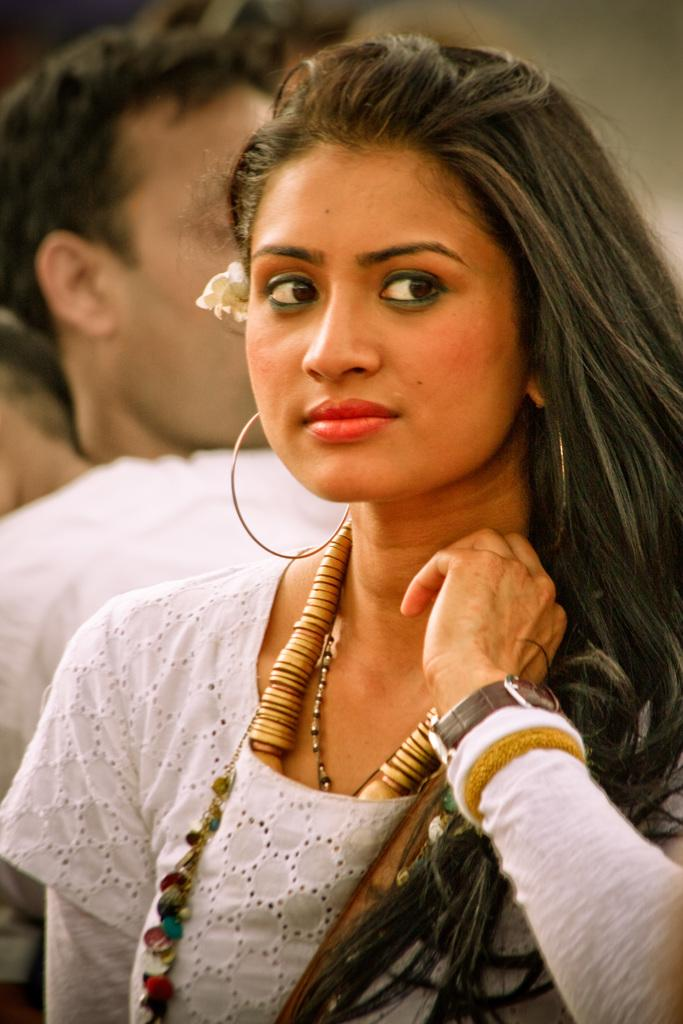Who is present in the image? There is a woman and a man in the image. What is the woman wearing? The woman is wearing a white top. Can you describe any accessories the woman is wearing? The woman has round earrings. What is the man wearing? The man is wearing a white T-shirt. What type of ornament is hanging from the man's neck in the image? There is no ornament hanging from the man's neck in the image. What kind of celery is being used as a prop in the image? There is no celery present in the image. 